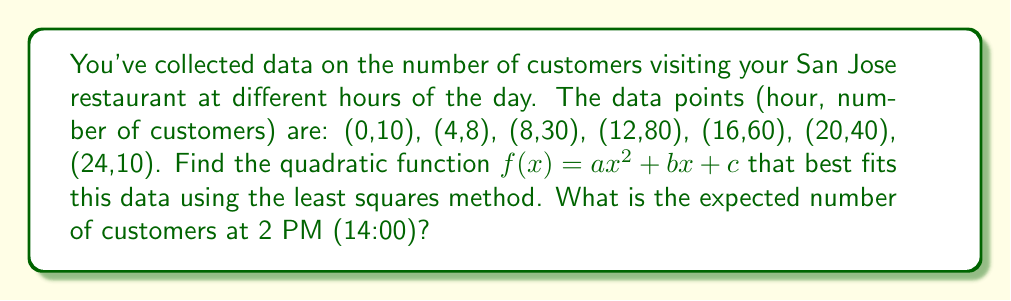Solve this math problem. 1) First, we need to set up the system of normal equations for the least squares method:

   $$\begin{cases}
   a\sum x_i^4 + b\sum x_i^3 + c\sum x_i^2 = \sum x_i^2y_i \\
   a\sum x_i^3 + b\sum x_i^2 + c\sum x_i = \sum x_iy_i \\
   a\sum x_i^2 + b\sum x_i + nc = \sum y_i
   \end{cases}$$

2) Calculate the sums:
   $\sum x_i^4 = 41,984$
   $\sum x_i^3 = 12,288$
   $\sum x_i^2 = 1,456$
   $\sum x_i = 84$
   $n = 7$
   $\sum y_i = 238$
   $\sum x_i^2y_i = 54,720$
   $\sum x_iy_i = 3,680$

3) Substitute these values into the system of equations:

   $$\begin{cases}
   41,984a + 12,288b + 1,456c = 54,720 \\
   12,288a + 1,456b + 84c = 3,680 \\
   1,456a + 84b + 7c = 238
   \end{cases}$$

4) Solve this system of equations (using a computer algebra system or matrix methods) to get:
   $a \approx -0.2232$
   $b \approx 6.7128$
   $c \approx 8.2857$

5) Therefore, the quadratic function is:
   $f(x) \approx -0.2232x^2 + 6.7128x + 8.2857$

6) To find the expected number of customers at 2 PM (14:00), substitute x = 14 into this function:
   $f(14) \approx -0.2232(14)^2 + 6.7128(14) + 8.2857 \approx 71.9999 \approx 72$
Answer: 72 customers 